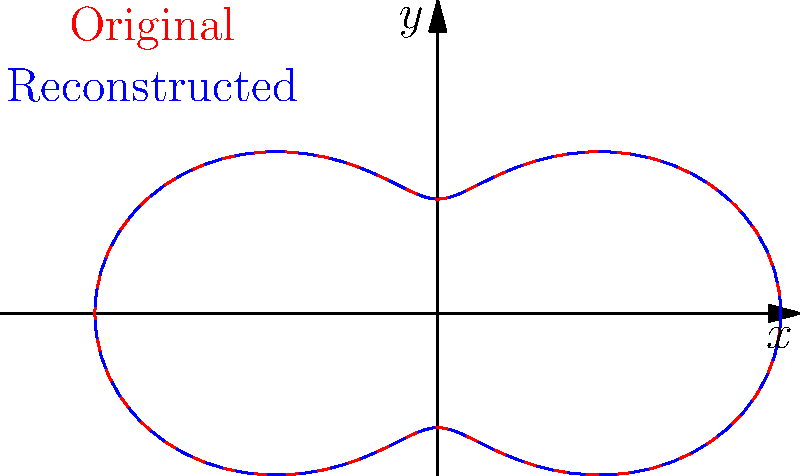In the polar coordinate graph showing breast shape outcomes, what is the maximum radial distance difference between the original and reconstructed breast contours? To find the maximum radial distance difference between the original and reconstructed breast contours, we need to analyze the polar graph:

1. The red solid line represents the original breast contour.
2. The blue dashed line represents the reconstructed breast contour.
3. The equation for both contours is $r(\theta) = 2 + \cos(2\theta)$.
4. The maximum difference occurs where the contours are furthest apart.
5. This happens at the "peaks" and "valleys" of the polar graph.
6. At $\theta = 0$ and $\theta = \pi$, we have maximum peaks.
7. At $\theta = \frac{\pi}{2}$ and $\theta = \frac{3\pi}{2}$, we have minimum valleys.
8. The radial distance at peaks: $r = 2 + 1 = 3$
9. The radial distance at valleys: $r = 2 - 1 = 1$
10. The difference between peaks and valleys: $3 - 1 = 2$

Therefore, the maximum radial distance difference between the original and reconstructed breast contours is 2 units.
Answer: 2 units 